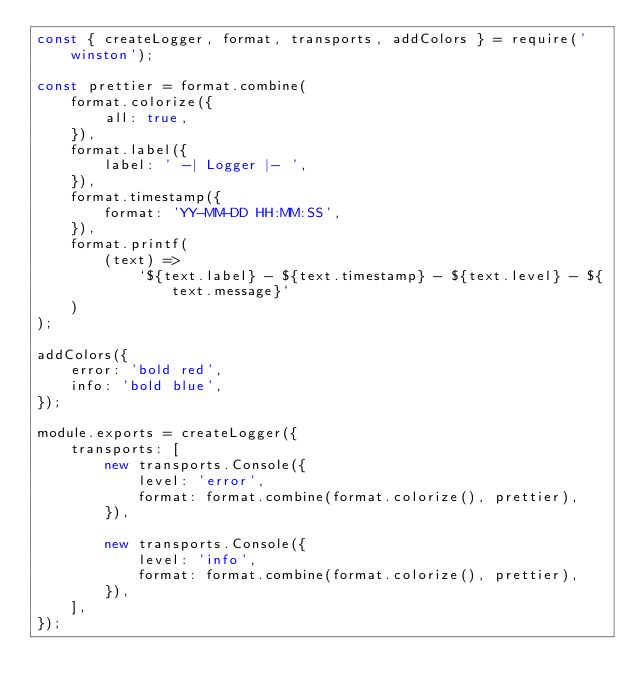Convert code to text. <code><loc_0><loc_0><loc_500><loc_500><_JavaScript_>const { createLogger, format, transports, addColors } = require('winston');

const prettier = format.combine(
    format.colorize({
        all: true,
    }),
    format.label({
        label: ' -| Logger |- ',
    }),
    format.timestamp({
        format: 'YY-MM-DD HH:MM:SS',
    }),
    format.printf(
        (text) =>
            `${text.label} - ${text.timestamp} - ${text.level} - ${text.message}`
    )
);

addColors({
    error: 'bold red',
    info: 'bold blue',
});

module.exports = createLogger({
    transports: [
        new transports.Console({
            level: 'error',
            format: format.combine(format.colorize(), prettier),
        }),

        new transports.Console({
            level: 'info',
            format: format.combine(format.colorize(), prettier),
        }),
    ],
});
</code> 